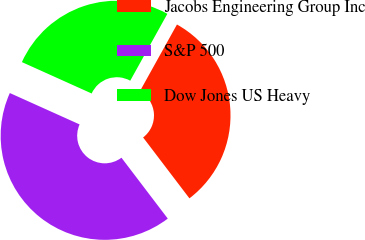Convert chart to OTSL. <chart><loc_0><loc_0><loc_500><loc_500><pie_chart><fcel>Jacobs Engineering Group Inc<fcel>S&P 500<fcel>Dow Jones US Heavy<nl><fcel>31.58%<fcel>42.08%<fcel>26.34%<nl></chart> 